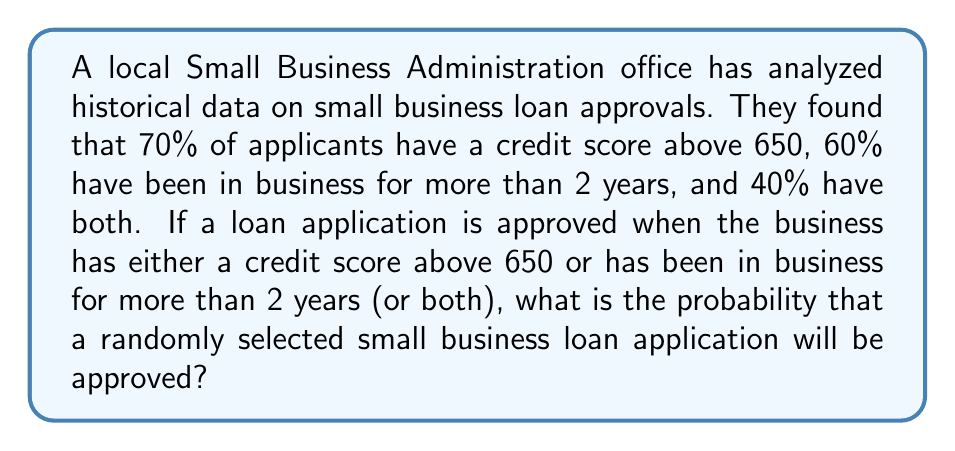Help me with this question. Let's approach this step-by-step using probability theory:

1) Define events:
   A: Credit score above 650
   B: In business for more than 2 years

2) Given probabilities:
   $P(A) = 0.70$
   $P(B) = 0.60$
   $P(A \cap B) = 0.40$

3) We need to find $P(A \cup B)$, which represents the probability of approval.

4) Using the addition rule of probability:

   $$P(A \cup B) = P(A) + P(B) - P(A \cap B)$$

5) Substituting the given values:

   $$P(A \cup B) = 0.70 + 0.60 - 0.40$$

6) Calculate:

   $$P(A \cup B) = 0.90 = 90\%$$

Therefore, the probability that a randomly selected small business loan application will be approved is 90%.
Answer: 90% 